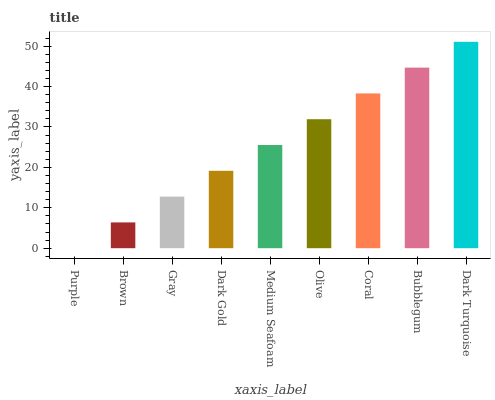Is Purple the minimum?
Answer yes or no. Yes. Is Dark Turquoise the maximum?
Answer yes or no. Yes. Is Brown the minimum?
Answer yes or no. No. Is Brown the maximum?
Answer yes or no. No. Is Brown greater than Purple?
Answer yes or no. Yes. Is Purple less than Brown?
Answer yes or no. Yes. Is Purple greater than Brown?
Answer yes or no. No. Is Brown less than Purple?
Answer yes or no. No. Is Medium Seafoam the high median?
Answer yes or no. Yes. Is Medium Seafoam the low median?
Answer yes or no. Yes. Is Coral the high median?
Answer yes or no. No. Is Bubblegum the low median?
Answer yes or no. No. 